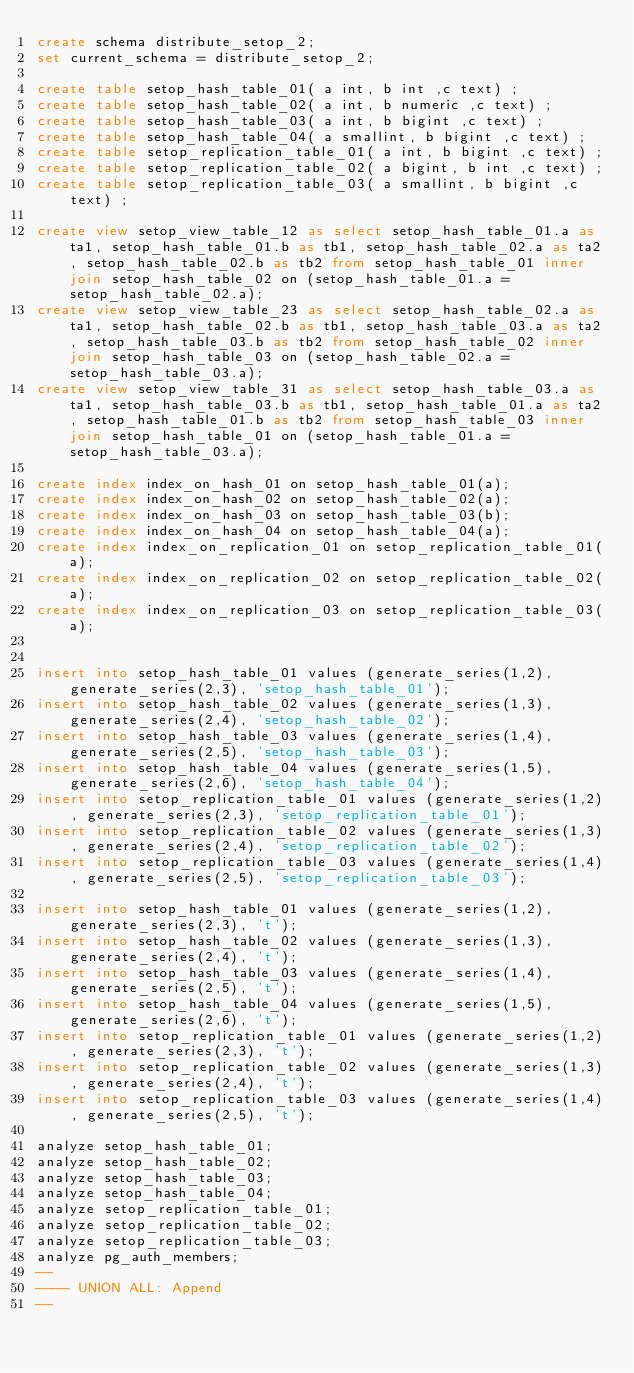<code> <loc_0><loc_0><loc_500><loc_500><_SQL_>create schema distribute_setop_2;
set current_schema = distribute_setop_2;

create table setop_hash_table_01( a int, b int ,c text) ;
create table setop_hash_table_02( a int, b numeric ,c text) ;
create table setop_hash_table_03( a int, b bigint ,c text) ;
create table setop_hash_table_04( a smallint, b bigint ,c text) ;
create table setop_replication_table_01( a int, b bigint ,c text) ;
create table setop_replication_table_02( a bigint, b int ,c text) ;
create table setop_replication_table_03( a smallint, b bigint ,c text) ;

create view setop_view_table_12 as select setop_hash_table_01.a as ta1, setop_hash_table_01.b as tb1, setop_hash_table_02.a as ta2, setop_hash_table_02.b as tb2 from setop_hash_table_01 inner join setop_hash_table_02 on (setop_hash_table_01.a = setop_hash_table_02.a);
create view setop_view_table_23 as select setop_hash_table_02.a as ta1, setop_hash_table_02.b as tb1, setop_hash_table_03.a as ta2, setop_hash_table_03.b as tb2 from setop_hash_table_02 inner join setop_hash_table_03 on (setop_hash_table_02.a = setop_hash_table_03.a);
create view setop_view_table_31 as select setop_hash_table_03.a as ta1, setop_hash_table_03.b as tb1, setop_hash_table_01.a as ta2, setop_hash_table_01.b as tb2 from setop_hash_table_03 inner join setop_hash_table_01 on (setop_hash_table_01.a = setop_hash_table_03.a);

create index index_on_hash_01 on setop_hash_table_01(a);
create index index_on_hash_02 on setop_hash_table_02(a);
create index index_on_hash_03 on setop_hash_table_03(b);
create index index_on_hash_04 on setop_hash_table_04(a);
create index index_on_replication_01 on setop_replication_table_01(a);
create index index_on_replication_02 on setop_replication_table_02(a);
create index index_on_replication_03 on setop_replication_table_03(a);


insert into setop_hash_table_01 values (generate_series(1,2), generate_series(2,3), 'setop_hash_table_01');
insert into setop_hash_table_02 values (generate_series(1,3), generate_series(2,4), 'setop_hash_table_02');
insert into setop_hash_table_03 values (generate_series(1,4), generate_series(2,5), 'setop_hash_table_03');
insert into setop_hash_table_04 values (generate_series(1,5), generate_series(2,6), 'setop_hash_table_04');
insert into setop_replication_table_01 values (generate_series(1,2), generate_series(2,3), 'setop_replication_table_01');
insert into setop_replication_table_02 values (generate_series(1,3), generate_series(2,4), 'setop_replication_table_02');
insert into setop_replication_table_03 values (generate_series(1,4), generate_series(2,5), 'setop_replication_table_03');

insert into setop_hash_table_01 values (generate_series(1,2), generate_series(2,3), 't');
insert into setop_hash_table_02 values (generate_series(1,3), generate_series(2,4), 't');
insert into setop_hash_table_03 values (generate_series(1,4), generate_series(2,5), 't');
insert into setop_hash_table_04 values (generate_series(1,5), generate_series(2,6), 't');
insert into setop_replication_table_01 values (generate_series(1,2), generate_series(2,3), 't');
insert into setop_replication_table_02 values (generate_series(1,3), generate_series(2,4), 't');
insert into setop_replication_table_03 values (generate_series(1,4), generate_series(2,5), 't');

analyze setop_hash_table_01;
analyze setop_hash_table_02;
analyze setop_hash_table_03;
analyze setop_hash_table_04;
analyze setop_replication_table_01;
analyze setop_replication_table_02;
analyze setop_replication_table_03;
analyze pg_auth_members;
--
---- UNION ALL: Append
--</code> 